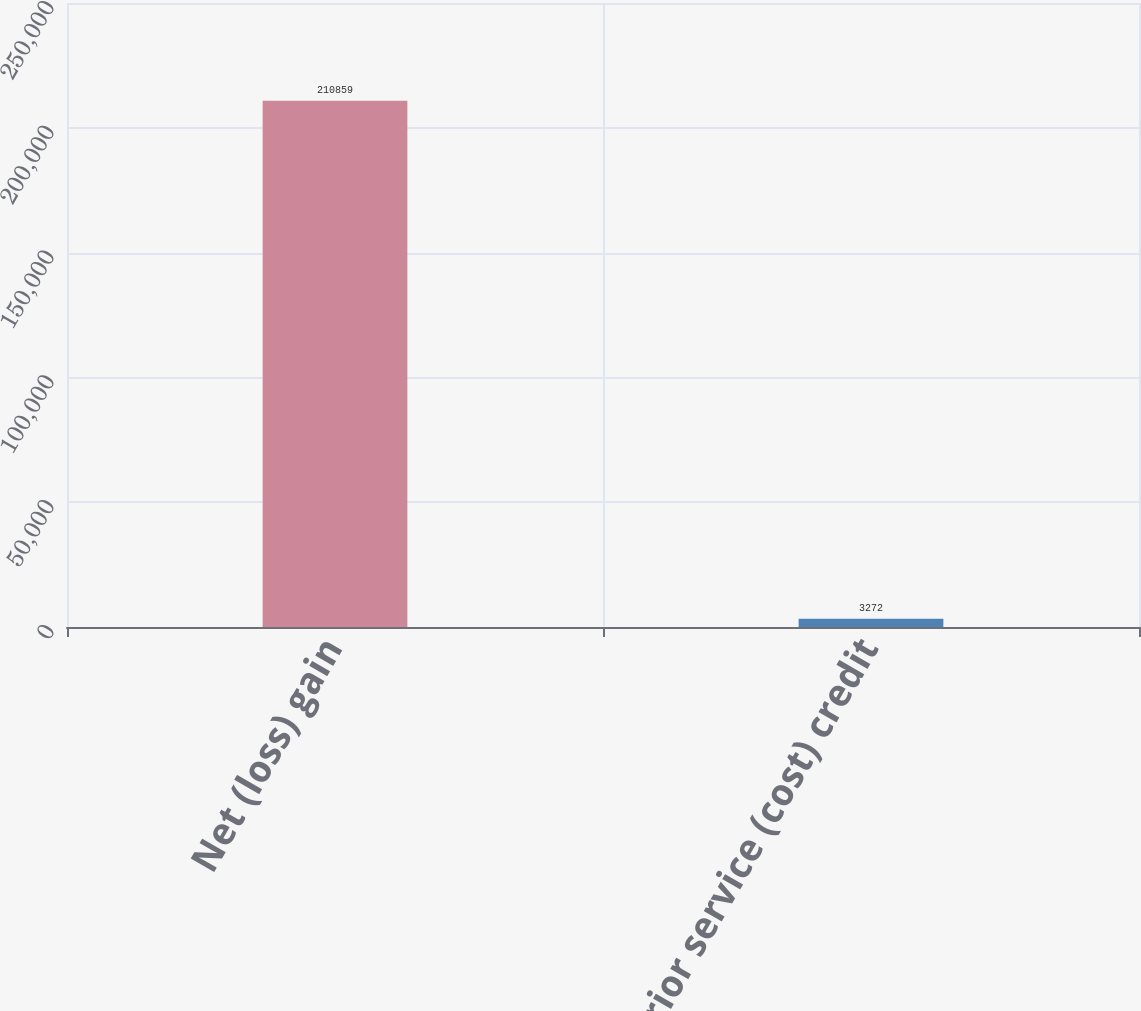Convert chart to OTSL. <chart><loc_0><loc_0><loc_500><loc_500><bar_chart><fcel>Net (loss) gain<fcel>Prior service (cost) credit<nl><fcel>210859<fcel>3272<nl></chart> 